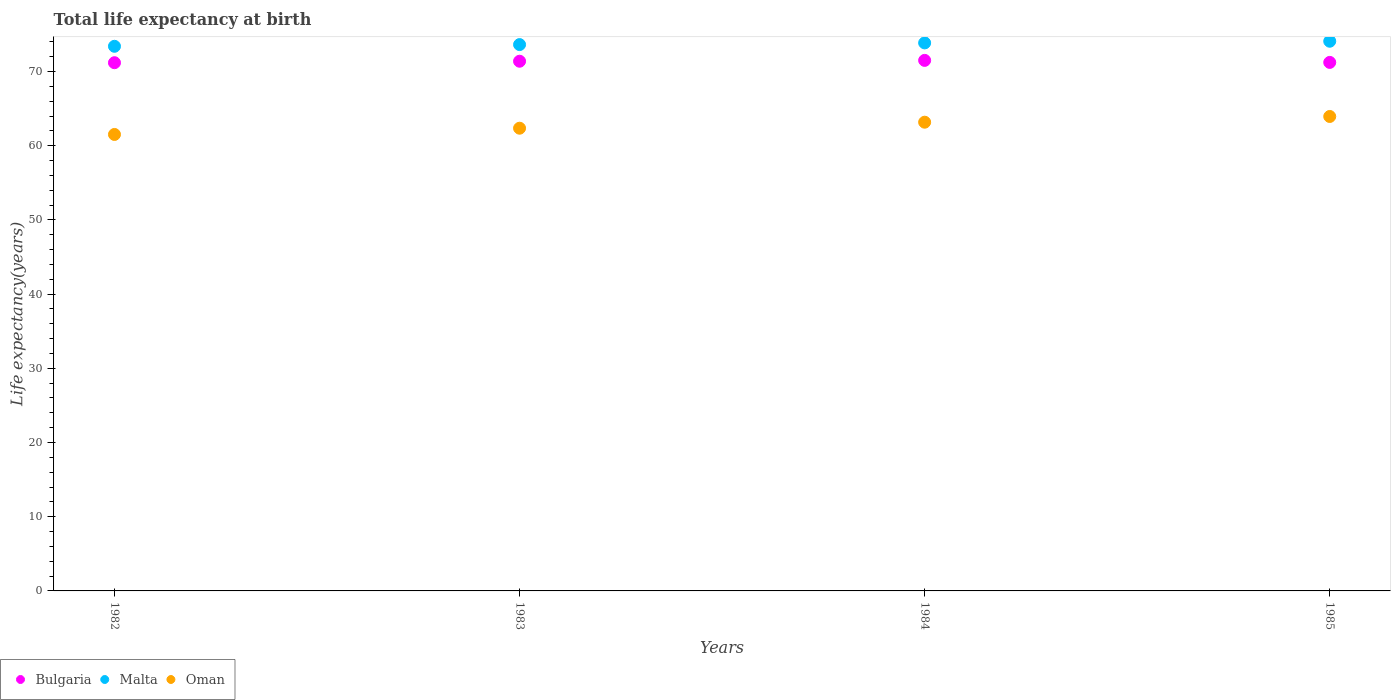How many different coloured dotlines are there?
Give a very brief answer. 3. Is the number of dotlines equal to the number of legend labels?
Make the answer very short. Yes. What is the life expectancy at birth in in Oman in 1984?
Offer a very short reply. 63.17. Across all years, what is the maximum life expectancy at birth in in Oman?
Offer a terse response. 63.94. Across all years, what is the minimum life expectancy at birth in in Oman?
Offer a terse response. 61.52. In which year was the life expectancy at birth in in Malta maximum?
Your answer should be very brief. 1985. What is the total life expectancy at birth in in Oman in the graph?
Your answer should be very brief. 250.99. What is the difference between the life expectancy at birth in in Oman in 1982 and that in 1985?
Ensure brevity in your answer.  -2.42. What is the difference between the life expectancy at birth in in Oman in 1984 and the life expectancy at birth in in Bulgaria in 1985?
Your answer should be very brief. -8.06. What is the average life expectancy at birth in in Bulgaria per year?
Keep it short and to the point. 71.33. In the year 1985, what is the difference between the life expectancy at birth in in Bulgaria and life expectancy at birth in in Malta?
Your response must be concise. -2.85. What is the ratio of the life expectancy at birth in in Oman in 1982 to that in 1985?
Provide a short and direct response. 0.96. Is the life expectancy at birth in in Bulgaria in 1984 less than that in 1985?
Keep it short and to the point. No. What is the difference between the highest and the second highest life expectancy at birth in in Bulgaria?
Your answer should be very brief. 0.11. What is the difference between the highest and the lowest life expectancy at birth in in Malta?
Make the answer very short. 0.68. Is the sum of the life expectancy at birth in in Oman in 1982 and 1985 greater than the maximum life expectancy at birth in in Bulgaria across all years?
Ensure brevity in your answer.  Yes. Is it the case that in every year, the sum of the life expectancy at birth in in Bulgaria and life expectancy at birth in in Oman  is greater than the life expectancy at birth in in Malta?
Provide a succinct answer. Yes. Is the life expectancy at birth in in Malta strictly less than the life expectancy at birth in in Oman over the years?
Provide a succinct answer. No. How many years are there in the graph?
Make the answer very short. 4. What is the difference between two consecutive major ticks on the Y-axis?
Your answer should be very brief. 10. Are the values on the major ticks of Y-axis written in scientific E-notation?
Make the answer very short. No. Does the graph contain any zero values?
Ensure brevity in your answer.  No. Does the graph contain grids?
Ensure brevity in your answer.  No. Where does the legend appear in the graph?
Your answer should be very brief. Bottom left. What is the title of the graph?
Give a very brief answer. Total life expectancy at birth. Does "Sub-Saharan Africa (developing only)" appear as one of the legend labels in the graph?
Offer a terse response. No. What is the label or title of the Y-axis?
Make the answer very short. Life expectancy(years). What is the Life expectancy(years) of Bulgaria in 1982?
Your response must be concise. 71.19. What is the Life expectancy(years) of Malta in 1982?
Offer a terse response. 73.4. What is the Life expectancy(years) in Oman in 1982?
Make the answer very short. 61.52. What is the Life expectancy(years) in Bulgaria in 1983?
Provide a succinct answer. 71.39. What is the Life expectancy(years) in Malta in 1983?
Your answer should be compact. 73.63. What is the Life expectancy(years) of Oman in 1983?
Your answer should be compact. 62.36. What is the Life expectancy(years) of Bulgaria in 1984?
Your answer should be compact. 71.5. What is the Life expectancy(years) of Malta in 1984?
Your answer should be compact. 73.86. What is the Life expectancy(years) of Oman in 1984?
Offer a very short reply. 63.17. What is the Life expectancy(years) of Bulgaria in 1985?
Your response must be concise. 71.23. What is the Life expectancy(years) in Malta in 1985?
Your response must be concise. 74.08. What is the Life expectancy(years) in Oman in 1985?
Make the answer very short. 63.94. Across all years, what is the maximum Life expectancy(years) in Bulgaria?
Make the answer very short. 71.5. Across all years, what is the maximum Life expectancy(years) of Malta?
Your response must be concise. 74.08. Across all years, what is the maximum Life expectancy(years) of Oman?
Provide a succinct answer. 63.94. Across all years, what is the minimum Life expectancy(years) in Bulgaria?
Keep it short and to the point. 71.19. Across all years, what is the minimum Life expectancy(years) of Malta?
Your answer should be very brief. 73.4. Across all years, what is the minimum Life expectancy(years) of Oman?
Make the answer very short. 61.52. What is the total Life expectancy(years) in Bulgaria in the graph?
Provide a short and direct response. 285.3. What is the total Life expectancy(years) of Malta in the graph?
Make the answer very short. 294.96. What is the total Life expectancy(years) of Oman in the graph?
Your response must be concise. 250.99. What is the difference between the Life expectancy(years) in Bulgaria in 1982 and that in 1983?
Your answer should be compact. -0.2. What is the difference between the Life expectancy(years) in Malta in 1982 and that in 1983?
Ensure brevity in your answer.  -0.23. What is the difference between the Life expectancy(years) in Oman in 1982 and that in 1983?
Offer a terse response. -0.84. What is the difference between the Life expectancy(years) in Bulgaria in 1982 and that in 1984?
Your response must be concise. -0.31. What is the difference between the Life expectancy(years) in Malta in 1982 and that in 1984?
Ensure brevity in your answer.  -0.46. What is the difference between the Life expectancy(years) of Oman in 1982 and that in 1984?
Offer a very short reply. -1.65. What is the difference between the Life expectancy(years) in Bulgaria in 1982 and that in 1985?
Provide a short and direct response. -0.04. What is the difference between the Life expectancy(years) in Malta in 1982 and that in 1985?
Provide a short and direct response. -0.68. What is the difference between the Life expectancy(years) of Oman in 1982 and that in 1985?
Make the answer very short. -2.42. What is the difference between the Life expectancy(years) of Bulgaria in 1983 and that in 1984?
Provide a succinct answer. -0.11. What is the difference between the Life expectancy(years) in Malta in 1983 and that in 1984?
Keep it short and to the point. -0.23. What is the difference between the Life expectancy(years) in Oman in 1983 and that in 1984?
Your response must be concise. -0.81. What is the difference between the Life expectancy(years) in Bulgaria in 1983 and that in 1985?
Offer a terse response. 0.16. What is the difference between the Life expectancy(years) in Malta in 1983 and that in 1985?
Offer a very short reply. -0.45. What is the difference between the Life expectancy(years) in Oman in 1983 and that in 1985?
Your answer should be compact. -1.58. What is the difference between the Life expectancy(years) of Bulgaria in 1984 and that in 1985?
Offer a very short reply. 0.27. What is the difference between the Life expectancy(years) of Malta in 1984 and that in 1985?
Your answer should be very brief. -0.23. What is the difference between the Life expectancy(years) of Oman in 1984 and that in 1985?
Offer a very short reply. -0.77. What is the difference between the Life expectancy(years) of Bulgaria in 1982 and the Life expectancy(years) of Malta in 1983?
Ensure brevity in your answer.  -2.44. What is the difference between the Life expectancy(years) in Bulgaria in 1982 and the Life expectancy(years) in Oman in 1983?
Provide a succinct answer. 8.83. What is the difference between the Life expectancy(years) in Malta in 1982 and the Life expectancy(years) in Oman in 1983?
Your answer should be very brief. 11.04. What is the difference between the Life expectancy(years) of Bulgaria in 1982 and the Life expectancy(years) of Malta in 1984?
Provide a short and direct response. -2.67. What is the difference between the Life expectancy(years) of Bulgaria in 1982 and the Life expectancy(years) of Oman in 1984?
Keep it short and to the point. 8.02. What is the difference between the Life expectancy(years) of Malta in 1982 and the Life expectancy(years) of Oman in 1984?
Your response must be concise. 10.23. What is the difference between the Life expectancy(years) in Bulgaria in 1982 and the Life expectancy(years) in Malta in 1985?
Offer a very short reply. -2.89. What is the difference between the Life expectancy(years) of Bulgaria in 1982 and the Life expectancy(years) of Oman in 1985?
Provide a short and direct response. 7.25. What is the difference between the Life expectancy(years) of Malta in 1982 and the Life expectancy(years) of Oman in 1985?
Provide a succinct answer. 9.46. What is the difference between the Life expectancy(years) in Bulgaria in 1983 and the Life expectancy(years) in Malta in 1984?
Give a very brief answer. -2.47. What is the difference between the Life expectancy(years) of Bulgaria in 1983 and the Life expectancy(years) of Oman in 1984?
Offer a very short reply. 8.22. What is the difference between the Life expectancy(years) in Malta in 1983 and the Life expectancy(years) in Oman in 1984?
Provide a succinct answer. 10.46. What is the difference between the Life expectancy(years) in Bulgaria in 1983 and the Life expectancy(years) in Malta in 1985?
Keep it short and to the point. -2.69. What is the difference between the Life expectancy(years) of Bulgaria in 1983 and the Life expectancy(years) of Oman in 1985?
Give a very brief answer. 7.45. What is the difference between the Life expectancy(years) in Malta in 1983 and the Life expectancy(years) in Oman in 1985?
Provide a succinct answer. 9.69. What is the difference between the Life expectancy(years) of Bulgaria in 1984 and the Life expectancy(years) of Malta in 1985?
Keep it short and to the point. -2.58. What is the difference between the Life expectancy(years) in Bulgaria in 1984 and the Life expectancy(years) in Oman in 1985?
Your answer should be very brief. 7.56. What is the difference between the Life expectancy(years) of Malta in 1984 and the Life expectancy(years) of Oman in 1985?
Offer a terse response. 9.91. What is the average Life expectancy(years) in Bulgaria per year?
Give a very brief answer. 71.33. What is the average Life expectancy(years) of Malta per year?
Provide a succinct answer. 73.74. What is the average Life expectancy(years) in Oman per year?
Your response must be concise. 62.75. In the year 1982, what is the difference between the Life expectancy(years) of Bulgaria and Life expectancy(years) of Malta?
Offer a very short reply. -2.21. In the year 1982, what is the difference between the Life expectancy(years) in Bulgaria and Life expectancy(years) in Oman?
Give a very brief answer. 9.67. In the year 1982, what is the difference between the Life expectancy(years) in Malta and Life expectancy(years) in Oman?
Give a very brief answer. 11.88. In the year 1983, what is the difference between the Life expectancy(years) in Bulgaria and Life expectancy(years) in Malta?
Provide a short and direct response. -2.24. In the year 1983, what is the difference between the Life expectancy(years) in Bulgaria and Life expectancy(years) in Oman?
Your answer should be very brief. 9.03. In the year 1983, what is the difference between the Life expectancy(years) of Malta and Life expectancy(years) of Oman?
Make the answer very short. 11.27. In the year 1984, what is the difference between the Life expectancy(years) in Bulgaria and Life expectancy(years) in Malta?
Provide a short and direct response. -2.36. In the year 1984, what is the difference between the Life expectancy(years) in Bulgaria and Life expectancy(years) in Oman?
Your answer should be compact. 8.33. In the year 1984, what is the difference between the Life expectancy(years) in Malta and Life expectancy(years) in Oman?
Keep it short and to the point. 10.69. In the year 1985, what is the difference between the Life expectancy(years) of Bulgaria and Life expectancy(years) of Malta?
Give a very brief answer. -2.85. In the year 1985, what is the difference between the Life expectancy(years) of Bulgaria and Life expectancy(years) of Oman?
Provide a short and direct response. 7.29. In the year 1985, what is the difference between the Life expectancy(years) in Malta and Life expectancy(years) in Oman?
Your response must be concise. 10.14. What is the ratio of the Life expectancy(years) in Malta in 1982 to that in 1983?
Keep it short and to the point. 1. What is the ratio of the Life expectancy(years) in Oman in 1982 to that in 1983?
Give a very brief answer. 0.99. What is the ratio of the Life expectancy(years) of Malta in 1982 to that in 1984?
Make the answer very short. 0.99. What is the ratio of the Life expectancy(years) in Oman in 1982 to that in 1984?
Keep it short and to the point. 0.97. What is the ratio of the Life expectancy(years) of Bulgaria in 1982 to that in 1985?
Provide a short and direct response. 1. What is the ratio of the Life expectancy(years) in Oman in 1982 to that in 1985?
Your response must be concise. 0.96. What is the ratio of the Life expectancy(years) in Bulgaria in 1983 to that in 1984?
Your response must be concise. 1. What is the ratio of the Life expectancy(years) in Oman in 1983 to that in 1984?
Make the answer very short. 0.99. What is the ratio of the Life expectancy(years) in Oman in 1983 to that in 1985?
Offer a terse response. 0.98. What is the ratio of the Life expectancy(years) of Malta in 1984 to that in 1985?
Provide a short and direct response. 1. What is the ratio of the Life expectancy(years) in Oman in 1984 to that in 1985?
Your answer should be compact. 0.99. What is the difference between the highest and the second highest Life expectancy(years) in Bulgaria?
Provide a succinct answer. 0.11. What is the difference between the highest and the second highest Life expectancy(years) in Malta?
Your answer should be compact. 0.23. What is the difference between the highest and the second highest Life expectancy(years) of Oman?
Offer a terse response. 0.77. What is the difference between the highest and the lowest Life expectancy(years) of Bulgaria?
Give a very brief answer. 0.31. What is the difference between the highest and the lowest Life expectancy(years) in Malta?
Offer a terse response. 0.68. What is the difference between the highest and the lowest Life expectancy(years) in Oman?
Provide a short and direct response. 2.42. 